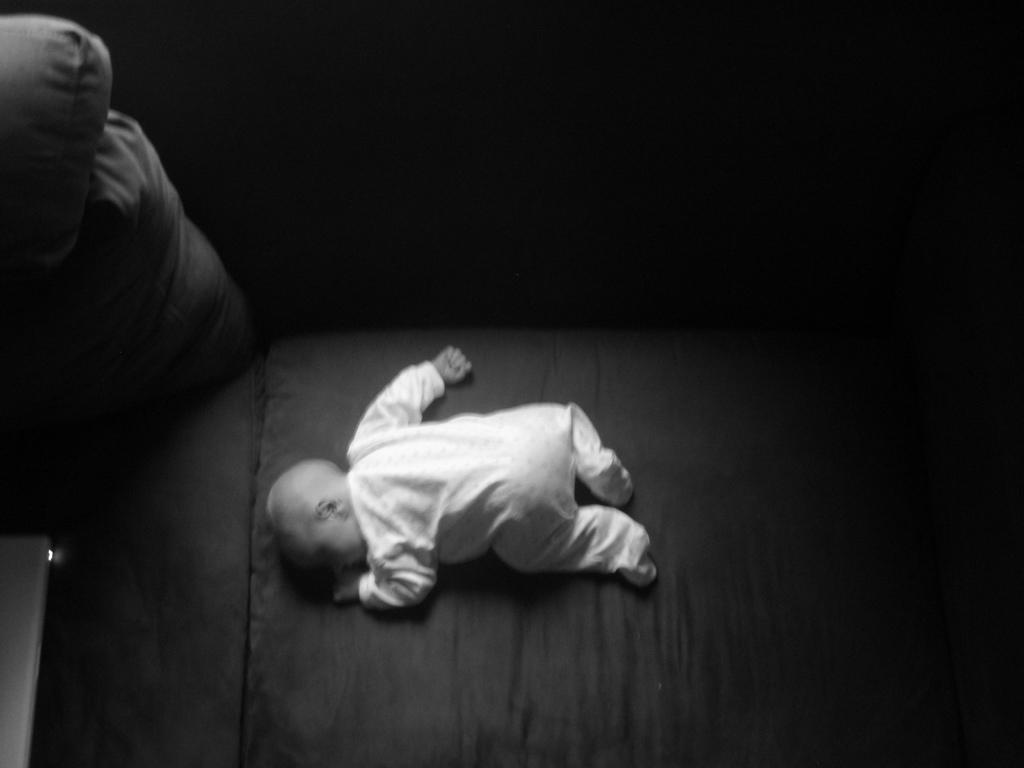What is the main subject of the image? There is a baby in the image. What is the baby's position in the image? The baby is lying on a platform. What other object can be seen in the image? There is a device in the image. How would you describe the lighting in the image? The background of the image is dark. What type of bath is the baby taking in the image? There is no indication of a bath in the image; the baby is lying on a platform. How does the baby move around in the dark background of the image? The baby is lying on a platform and does not move around in the image. 